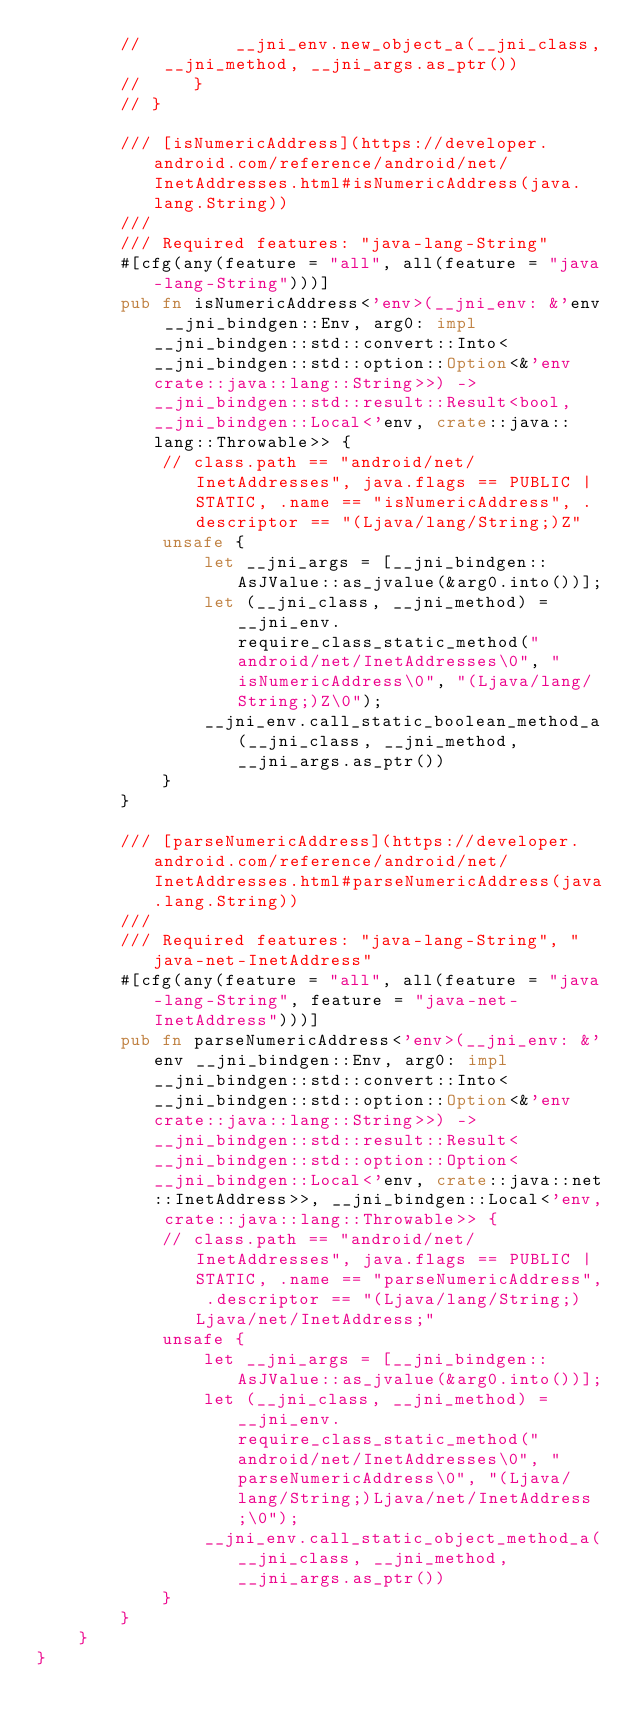Convert code to text. <code><loc_0><loc_0><loc_500><loc_500><_Rust_>        //         __jni_env.new_object_a(__jni_class, __jni_method, __jni_args.as_ptr())
        //     }
        // }

        /// [isNumericAddress](https://developer.android.com/reference/android/net/InetAddresses.html#isNumericAddress(java.lang.String))
        ///
        /// Required features: "java-lang-String"
        #[cfg(any(feature = "all", all(feature = "java-lang-String")))]
        pub fn isNumericAddress<'env>(__jni_env: &'env __jni_bindgen::Env, arg0: impl __jni_bindgen::std::convert::Into<__jni_bindgen::std::option::Option<&'env crate::java::lang::String>>) -> __jni_bindgen::std::result::Result<bool, __jni_bindgen::Local<'env, crate::java::lang::Throwable>> {
            // class.path == "android/net/InetAddresses", java.flags == PUBLIC | STATIC, .name == "isNumericAddress", .descriptor == "(Ljava/lang/String;)Z"
            unsafe {
                let __jni_args = [__jni_bindgen::AsJValue::as_jvalue(&arg0.into())];
                let (__jni_class, __jni_method) = __jni_env.require_class_static_method("android/net/InetAddresses\0", "isNumericAddress\0", "(Ljava/lang/String;)Z\0");
                __jni_env.call_static_boolean_method_a(__jni_class, __jni_method, __jni_args.as_ptr())
            }
        }

        /// [parseNumericAddress](https://developer.android.com/reference/android/net/InetAddresses.html#parseNumericAddress(java.lang.String))
        ///
        /// Required features: "java-lang-String", "java-net-InetAddress"
        #[cfg(any(feature = "all", all(feature = "java-lang-String", feature = "java-net-InetAddress")))]
        pub fn parseNumericAddress<'env>(__jni_env: &'env __jni_bindgen::Env, arg0: impl __jni_bindgen::std::convert::Into<__jni_bindgen::std::option::Option<&'env crate::java::lang::String>>) -> __jni_bindgen::std::result::Result<__jni_bindgen::std::option::Option<__jni_bindgen::Local<'env, crate::java::net::InetAddress>>, __jni_bindgen::Local<'env, crate::java::lang::Throwable>> {
            // class.path == "android/net/InetAddresses", java.flags == PUBLIC | STATIC, .name == "parseNumericAddress", .descriptor == "(Ljava/lang/String;)Ljava/net/InetAddress;"
            unsafe {
                let __jni_args = [__jni_bindgen::AsJValue::as_jvalue(&arg0.into())];
                let (__jni_class, __jni_method) = __jni_env.require_class_static_method("android/net/InetAddresses\0", "parseNumericAddress\0", "(Ljava/lang/String;)Ljava/net/InetAddress;\0");
                __jni_env.call_static_object_method_a(__jni_class, __jni_method, __jni_args.as_ptr())
            }
        }
    }
}
</code> 